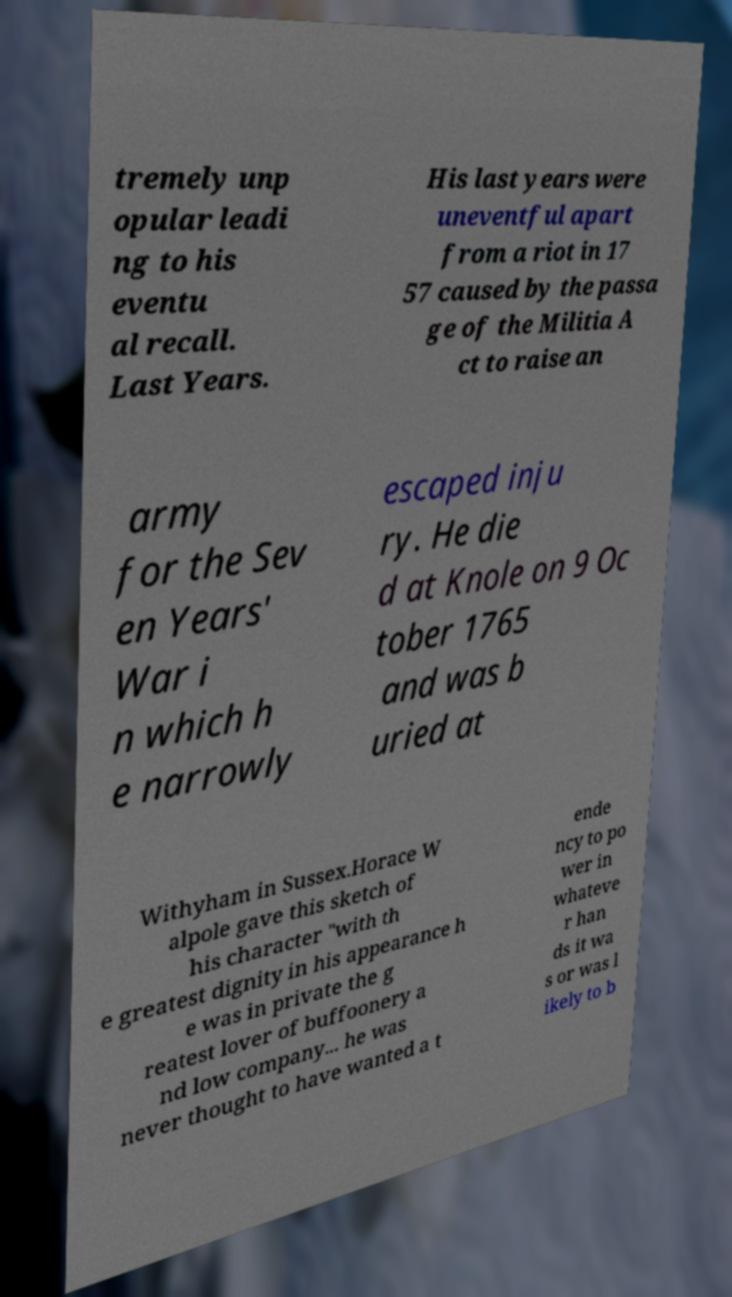What messages or text are displayed in this image? I need them in a readable, typed format. tremely unp opular leadi ng to his eventu al recall. Last Years. His last years were uneventful apart from a riot in 17 57 caused by the passa ge of the Militia A ct to raise an army for the Sev en Years' War i n which h e narrowly escaped inju ry. He die d at Knole on 9 Oc tober 1765 and was b uried at Withyham in Sussex.Horace W alpole gave this sketch of his character "with th e greatest dignity in his appearance h e was in private the g reatest lover of buffoonery a nd low company... he was never thought to have wanted a t ende ncy to po wer in whateve r han ds it wa s or was l ikely to b 